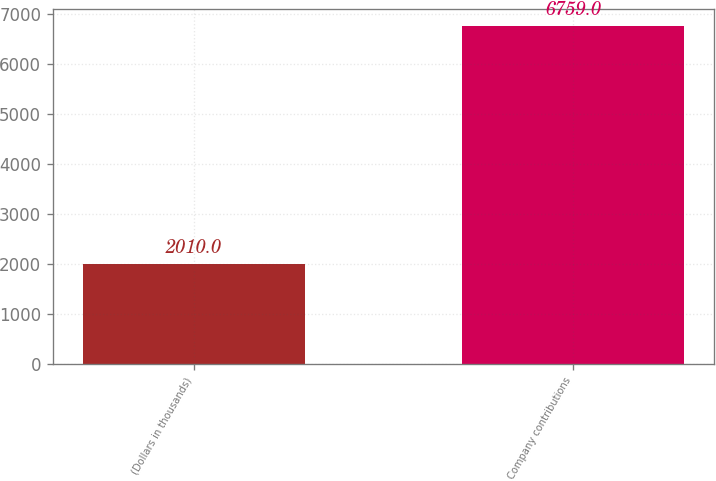Convert chart. <chart><loc_0><loc_0><loc_500><loc_500><bar_chart><fcel>(Dollars in thousands)<fcel>Company contributions<nl><fcel>2010<fcel>6759<nl></chart> 